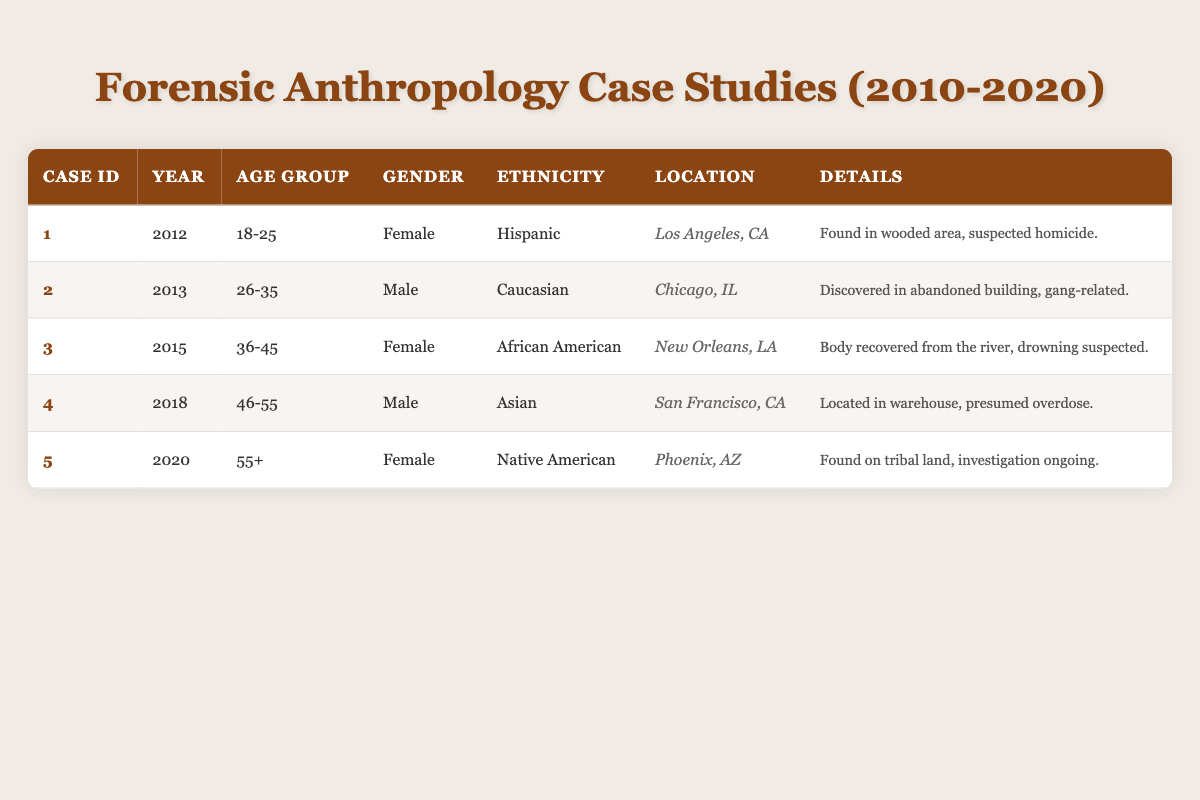What is the gender of the individual in case ID 3? Referring to the table, for case ID 3, the gender is listed as Female.
Answer: Female How many cases involve individuals aged 18-25? The table shows one case (case ID 1) with an individual in the age group of 18-25.
Answer: 1 Is there a case from 2018 related to homicide? The details of the case from 2018 (case ID 4) describe it as presumed overdose, not homicide.
Answer: No What year had the oldest individual in the case studies? The case with the oldest individual (55+) is from the year 2020 (case ID 5).
Answer: 2020 What are the ethnicities represented in the case studies? The table provides three distinct ethnicities: Hispanic (case ID 1), Caucasian (case ID 2), African American (case ID 3), Asian (case ID 4), and Native American (case ID 5).
Answer: Hispanic, Caucasian, African American, Asian, Native American How many cases involve male individuals? A quick look at the table shows two cases that involve males: case ID 2 and case ID 4.
Answer: 2 In which city was the case with individuals aged 36-45 found? According to the table, the case with an individual aged 36-45 (case ID 3) was located in New Orleans, LA.
Answer: New Orleans, LA What percentage of the cases involves individuals aged 46 and above? There are 5 cases total: 1 case (20%) in the age group 46-55 and 1 case (20%) in the age group 55+. That totals to 40% of the cases.
Answer: 40% What is the most recent year represented in the case studies, and which gender was involved? The most recent year is 2020, involving a female individual (case ID 5).
Answer: 2020, Female 